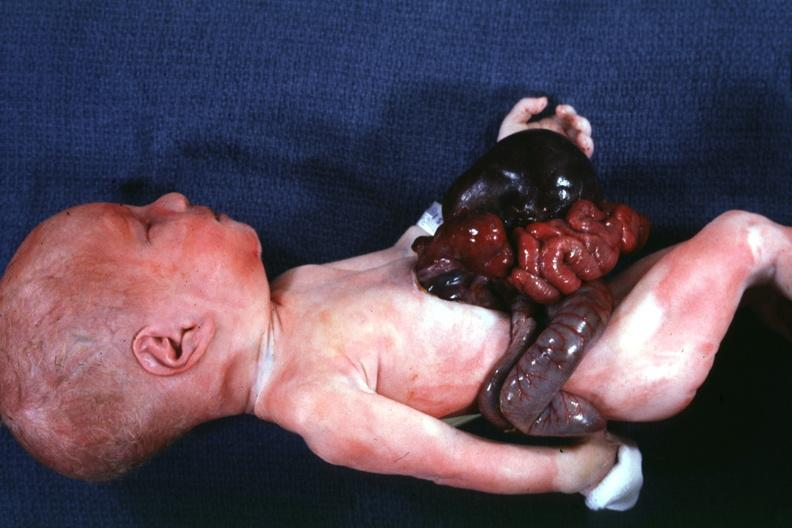what is present?
Answer the question using a single word or phrase. Omphalocele 